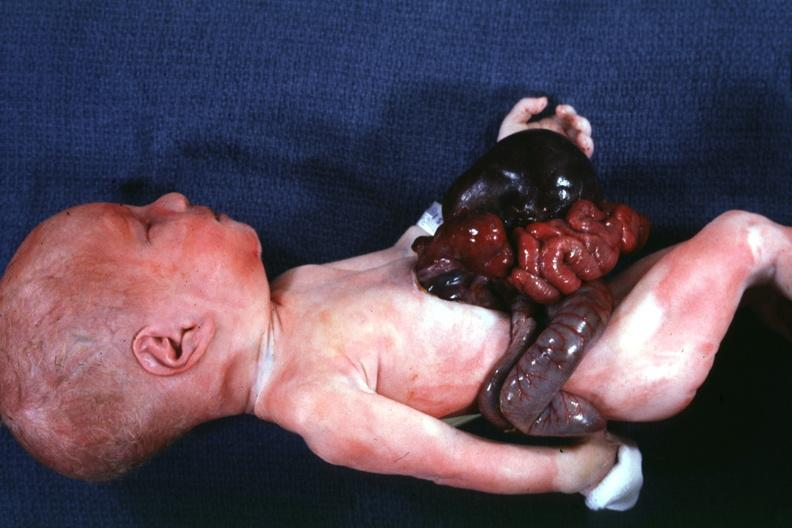what is present?
Answer the question using a single word or phrase. Omphalocele 